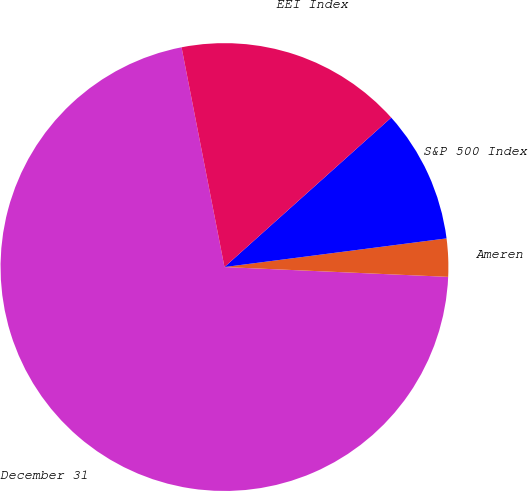Convert chart. <chart><loc_0><loc_0><loc_500><loc_500><pie_chart><fcel>December 31<fcel>Ameren<fcel>S&P 500 Index<fcel>EEI Index<nl><fcel>71.24%<fcel>2.74%<fcel>9.59%<fcel>16.44%<nl></chart> 